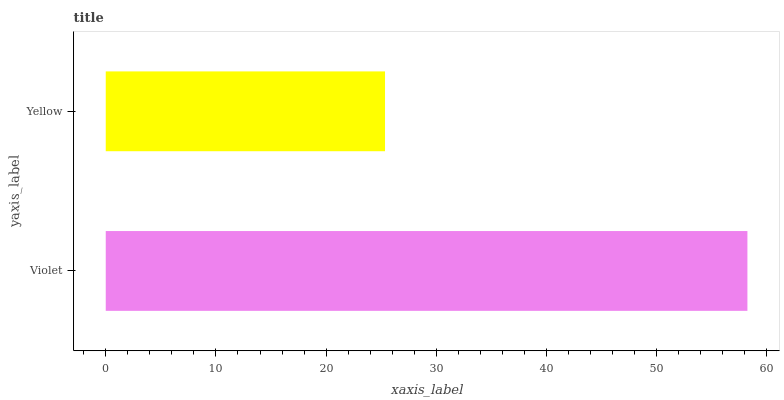Is Yellow the minimum?
Answer yes or no. Yes. Is Violet the maximum?
Answer yes or no. Yes. Is Yellow the maximum?
Answer yes or no. No. Is Violet greater than Yellow?
Answer yes or no. Yes. Is Yellow less than Violet?
Answer yes or no. Yes. Is Yellow greater than Violet?
Answer yes or no. No. Is Violet less than Yellow?
Answer yes or no. No. Is Violet the high median?
Answer yes or no. Yes. Is Yellow the low median?
Answer yes or no. Yes. Is Yellow the high median?
Answer yes or no. No. Is Violet the low median?
Answer yes or no. No. 